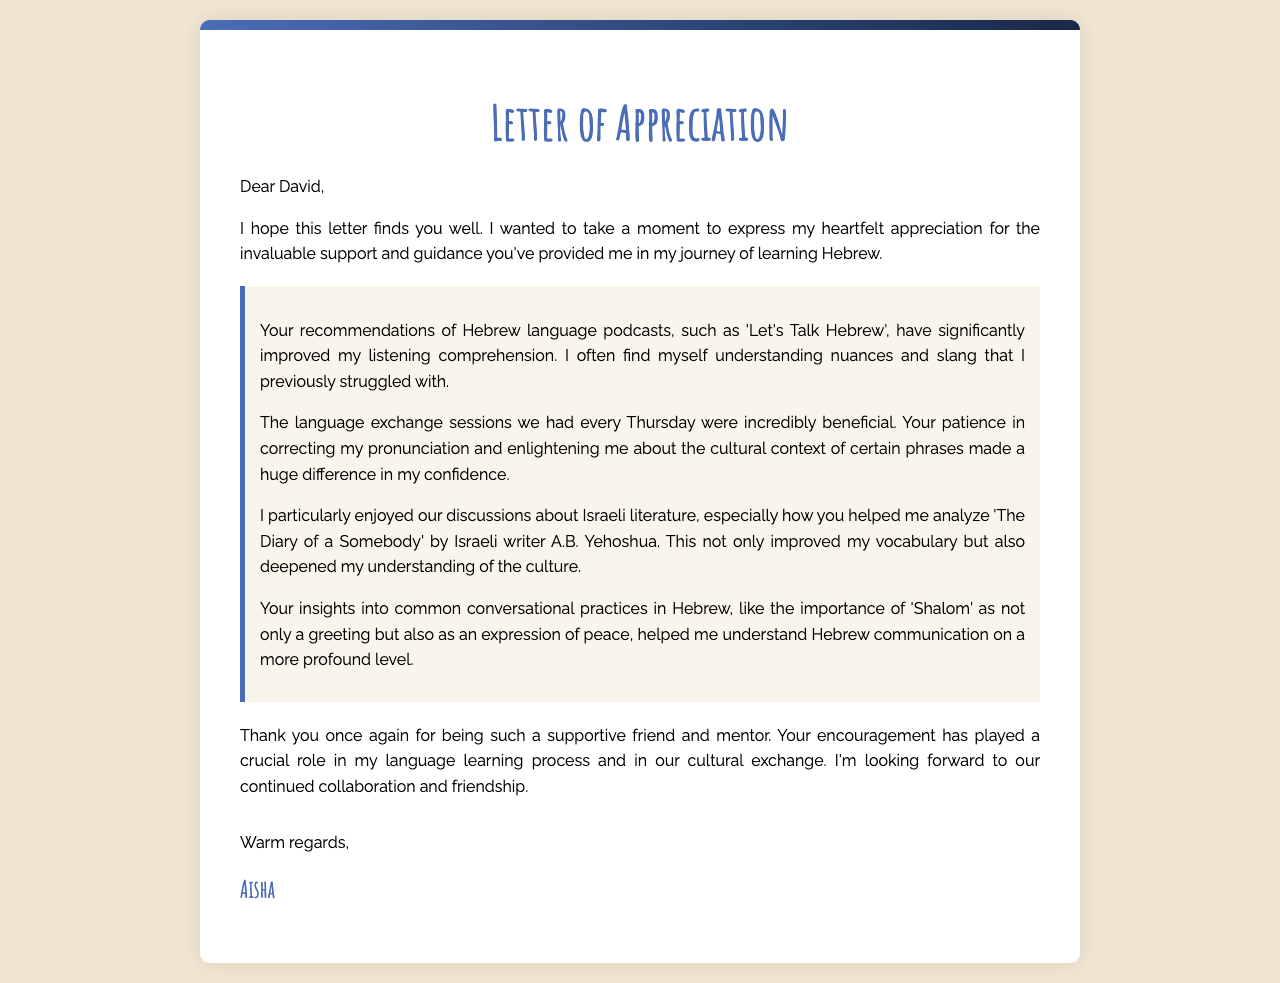What is the name of the friend being thanked? The friend being thanked in the letter is mentioned at the beginning, it is David.
Answer: David What language is Aisha learning? The letter discusses Aisha's journey of learning Hebrew.
Answer: Hebrew How often did Aisha and David meet for language exchange sessions? The document states they had language exchange sessions every Thursday.
Answer: every Thursday Which Hebrew podcast did David recommend? Aisha mentions that David recommended the podcast 'Let's Talk Hebrew'.
Answer: 'Let's Talk Hebrew' What is one literary work discussed in the letter? The letter mentions a discussion about 'The Diary of a Somebody' by A.B. Yehoshua.
Answer: 'The Diary of a Somebody' What aspect of communication did Aisha learn about from David? Aisha learned about the importance of 'Shalom' in Hebrew communication.
Answer: 'Shalom' What type of document is this? The document is classified as a letter of appreciation.
Answer: letter of appreciation What is Aisha's final expression towards David in the letter? Aisha concludes the letter by expressing warm regards.
Answer: warm regards How has David's guidance impacted Aisha's confidence? Aisha notes that David's patience and guidance made a huge difference in her confidence.
Answer: huge difference in confidence 